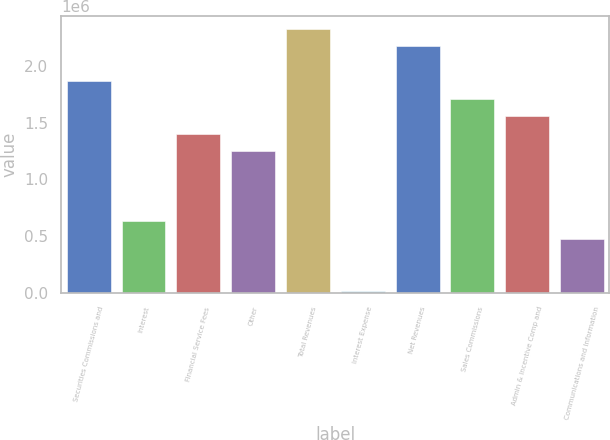<chart> <loc_0><loc_0><loc_500><loc_500><bar_chart><fcel>Securities Commissions and<fcel>Interest<fcel>Financial Service Fees<fcel>Other<fcel>Total Revenues<fcel>Interest Expense<fcel>Net Revenues<fcel>Sales Commissions<fcel>Admin & Incentive Comp and<fcel>Communications and Information<nl><fcel>1.86598e+06<fcel>631919<fcel>1.4032e+06<fcel>1.24895e+06<fcel>2.32875e+06<fcel>14891<fcel>2.17449e+06<fcel>1.71172e+06<fcel>1.55746e+06<fcel>477662<nl></chart> 